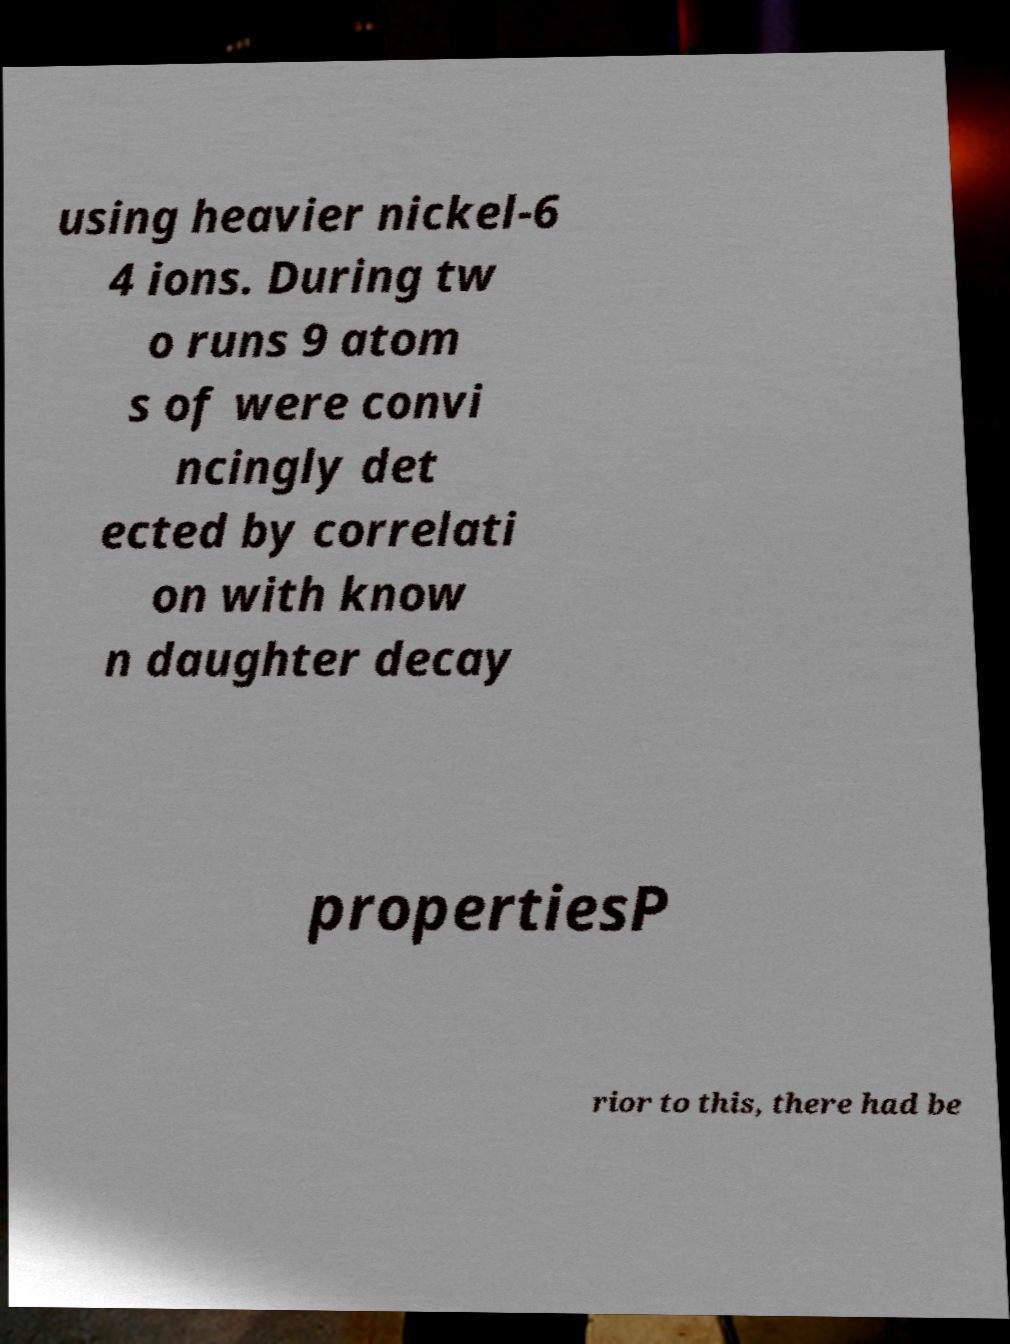Could you extract and type out the text from this image? using heavier nickel-6 4 ions. During tw o runs 9 atom s of were convi ncingly det ected by correlati on with know n daughter decay propertiesP rior to this, there had be 